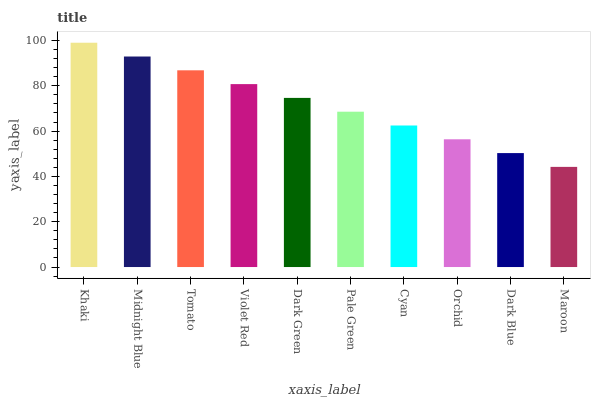Is Maroon the minimum?
Answer yes or no. Yes. Is Khaki the maximum?
Answer yes or no. Yes. Is Midnight Blue the minimum?
Answer yes or no. No. Is Midnight Blue the maximum?
Answer yes or no. No. Is Khaki greater than Midnight Blue?
Answer yes or no. Yes. Is Midnight Blue less than Khaki?
Answer yes or no. Yes. Is Midnight Blue greater than Khaki?
Answer yes or no. No. Is Khaki less than Midnight Blue?
Answer yes or no. No. Is Dark Green the high median?
Answer yes or no. Yes. Is Pale Green the low median?
Answer yes or no. Yes. Is Cyan the high median?
Answer yes or no. No. Is Tomato the low median?
Answer yes or no. No. 